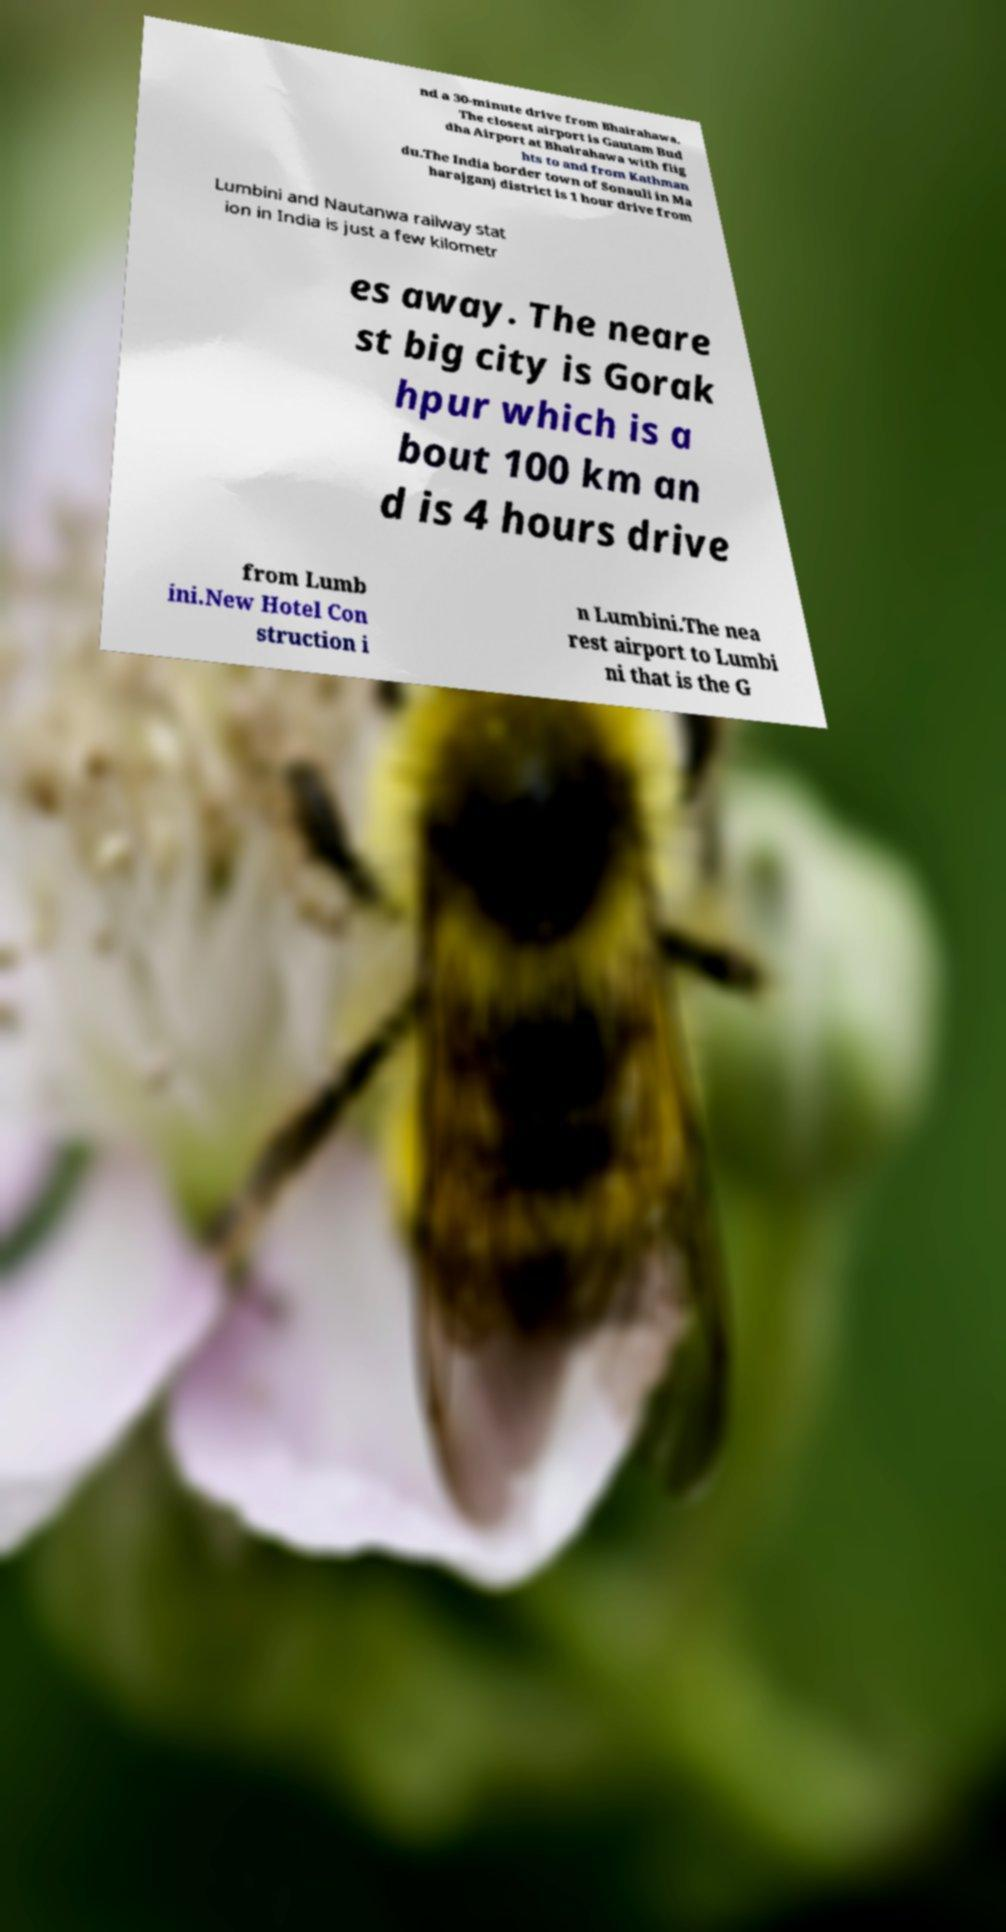What messages or text are displayed in this image? I need them in a readable, typed format. nd a 30-minute drive from Bhairahawa. The closest airport is Gautam Bud dha Airport at Bhairahawa with flig hts to and from Kathman du.The India border town of Sonauli in Ma harajganj district is 1 hour drive from Lumbini and Nautanwa railway stat ion in India is just a few kilometr es away. The neare st big city is Gorak hpur which is a bout 100 km an d is 4 hours drive from Lumb ini.New Hotel Con struction i n Lumbini.The nea rest airport to Lumbi ni that is the G 